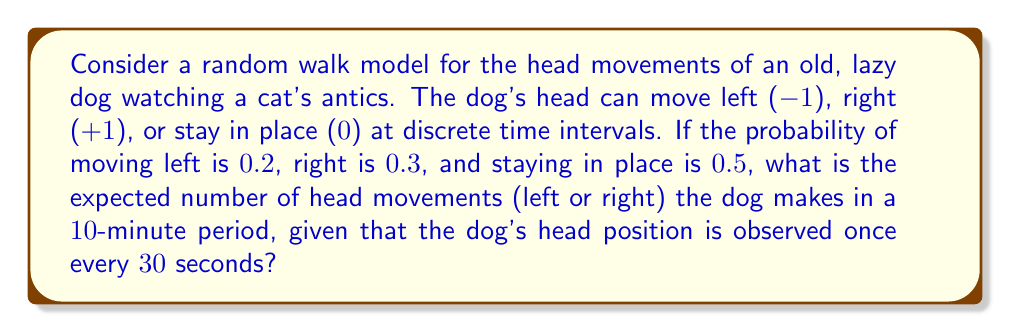What is the answer to this math problem? Let's approach this step-by-step:

1) First, we need to determine how many observations are made in 10 minutes:
   $$\text{Number of observations} = \frac{10 \text{ minutes}}{0.5 \text{ minutes per observation}} = 20 \text{ observations}$$

2) The probability of the dog moving its head (either left or right) in a single observation is:
   $$P(\text{movement}) = P(\text{left}) + P(\text{right}) = 0.2 + 0.3 = 0.5$$

3) This scenario follows a binomial distribution, where each observation is an independent trial with a probability of 0.5 for a head movement.

4) The expected number of successes (head movements) in a binomial distribution is given by:
   $$E(X) = np$$
   where $n$ is the number of trials and $p$ is the probability of success on each trial.

5) In this case:
   $$E(X) = 20 \cdot 0.5 = 10$$

Therefore, the expected number of head movements in 10 minutes is 10.
Answer: 10 movements 